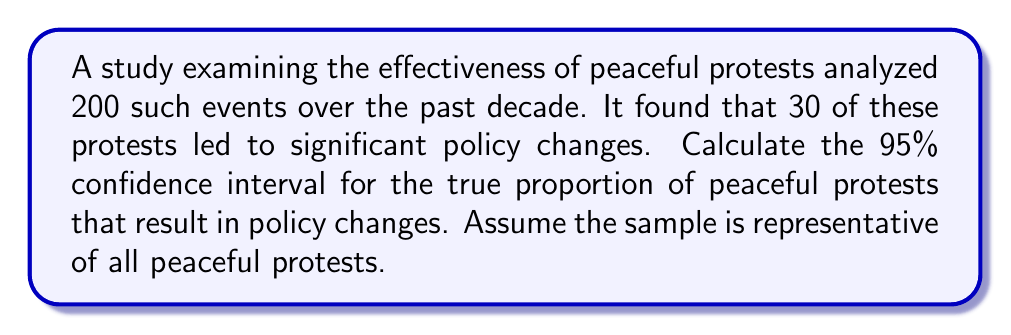Provide a solution to this math problem. Let's approach this step-by-step:

1) First, we need to calculate the sample proportion:
   $\hat{p} = \frac{\text{number of successes}}{\text{total sample size}} = \frac{30}{200} = 0.15$

2) The formula for the confidence interval is:
   $$\hat{p} \pm z^* \sqrt{\frac{\hat{p}(1-\hat{p})}{n}}$$
   where $z^*$ is the critical value for the desired confidence level.

3) For a 95% confidence interval, $z^* = 1.96$

4) Now, let's plug in our values:
   $n = 200$
   $\hat{p} = 0.15$

5) Calculate the standard error:
   $$SE = \sqrt{\frac{\hat{p}(1-\hat{p})}{n}} = \sqrt{\frac{0.15(1-0.15)}{200}} = \sqrt{\frac{0.1275}{200}} = 0.0252$$

6) Now we can calculate the margin of error:
   $$ME = z^* \cdot SE = 1.96 \cdot 0.0252 = 0.0494$$

7) Finally, we can compute the confidence interval:
   Lower bound: $0.15 - 0.0494 = 0.1006$
   Upper bound: $0.15 + 0.0494 = 0.1994$

8) Rounding to three decimal places:
   $(0.101, 0.199)$
Answer: (0.101, 0.199) 